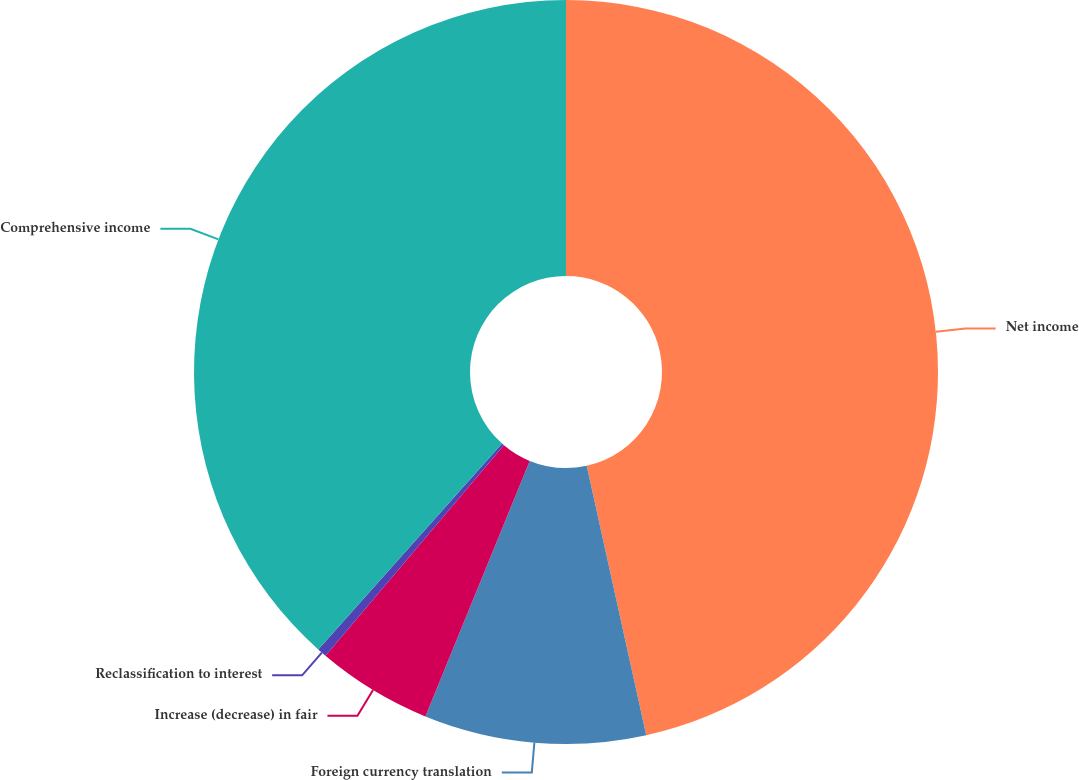Convert chart. <chart><loc_0><loc_0><loc_500><loc_500><pie_chart><fcel>Net income<fcel>Foreign currency translation<fcel>Increase (decrease) in fair<fcel>Reclassification to interest<fcel>Comprehensive income<nl><fcel>46.54%<fcel>9.63%<fcel>5.02%<fcel>0.41%<fcel>38.4%<nl></chart> 